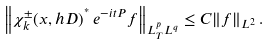Convert formula to latex. <formula><loc_0><loc_0><loc_500><loc_500>\left \| \chi ^ { \pm } _ { k } ( x , h D ) ^ { ^ { * } } \, e ^ { - i t P } f \right \| _ { L ^ { p } _ { T } L ^ { q } } \leq C \| f \| _ { L ^ { 2 } } \, .</formula> 